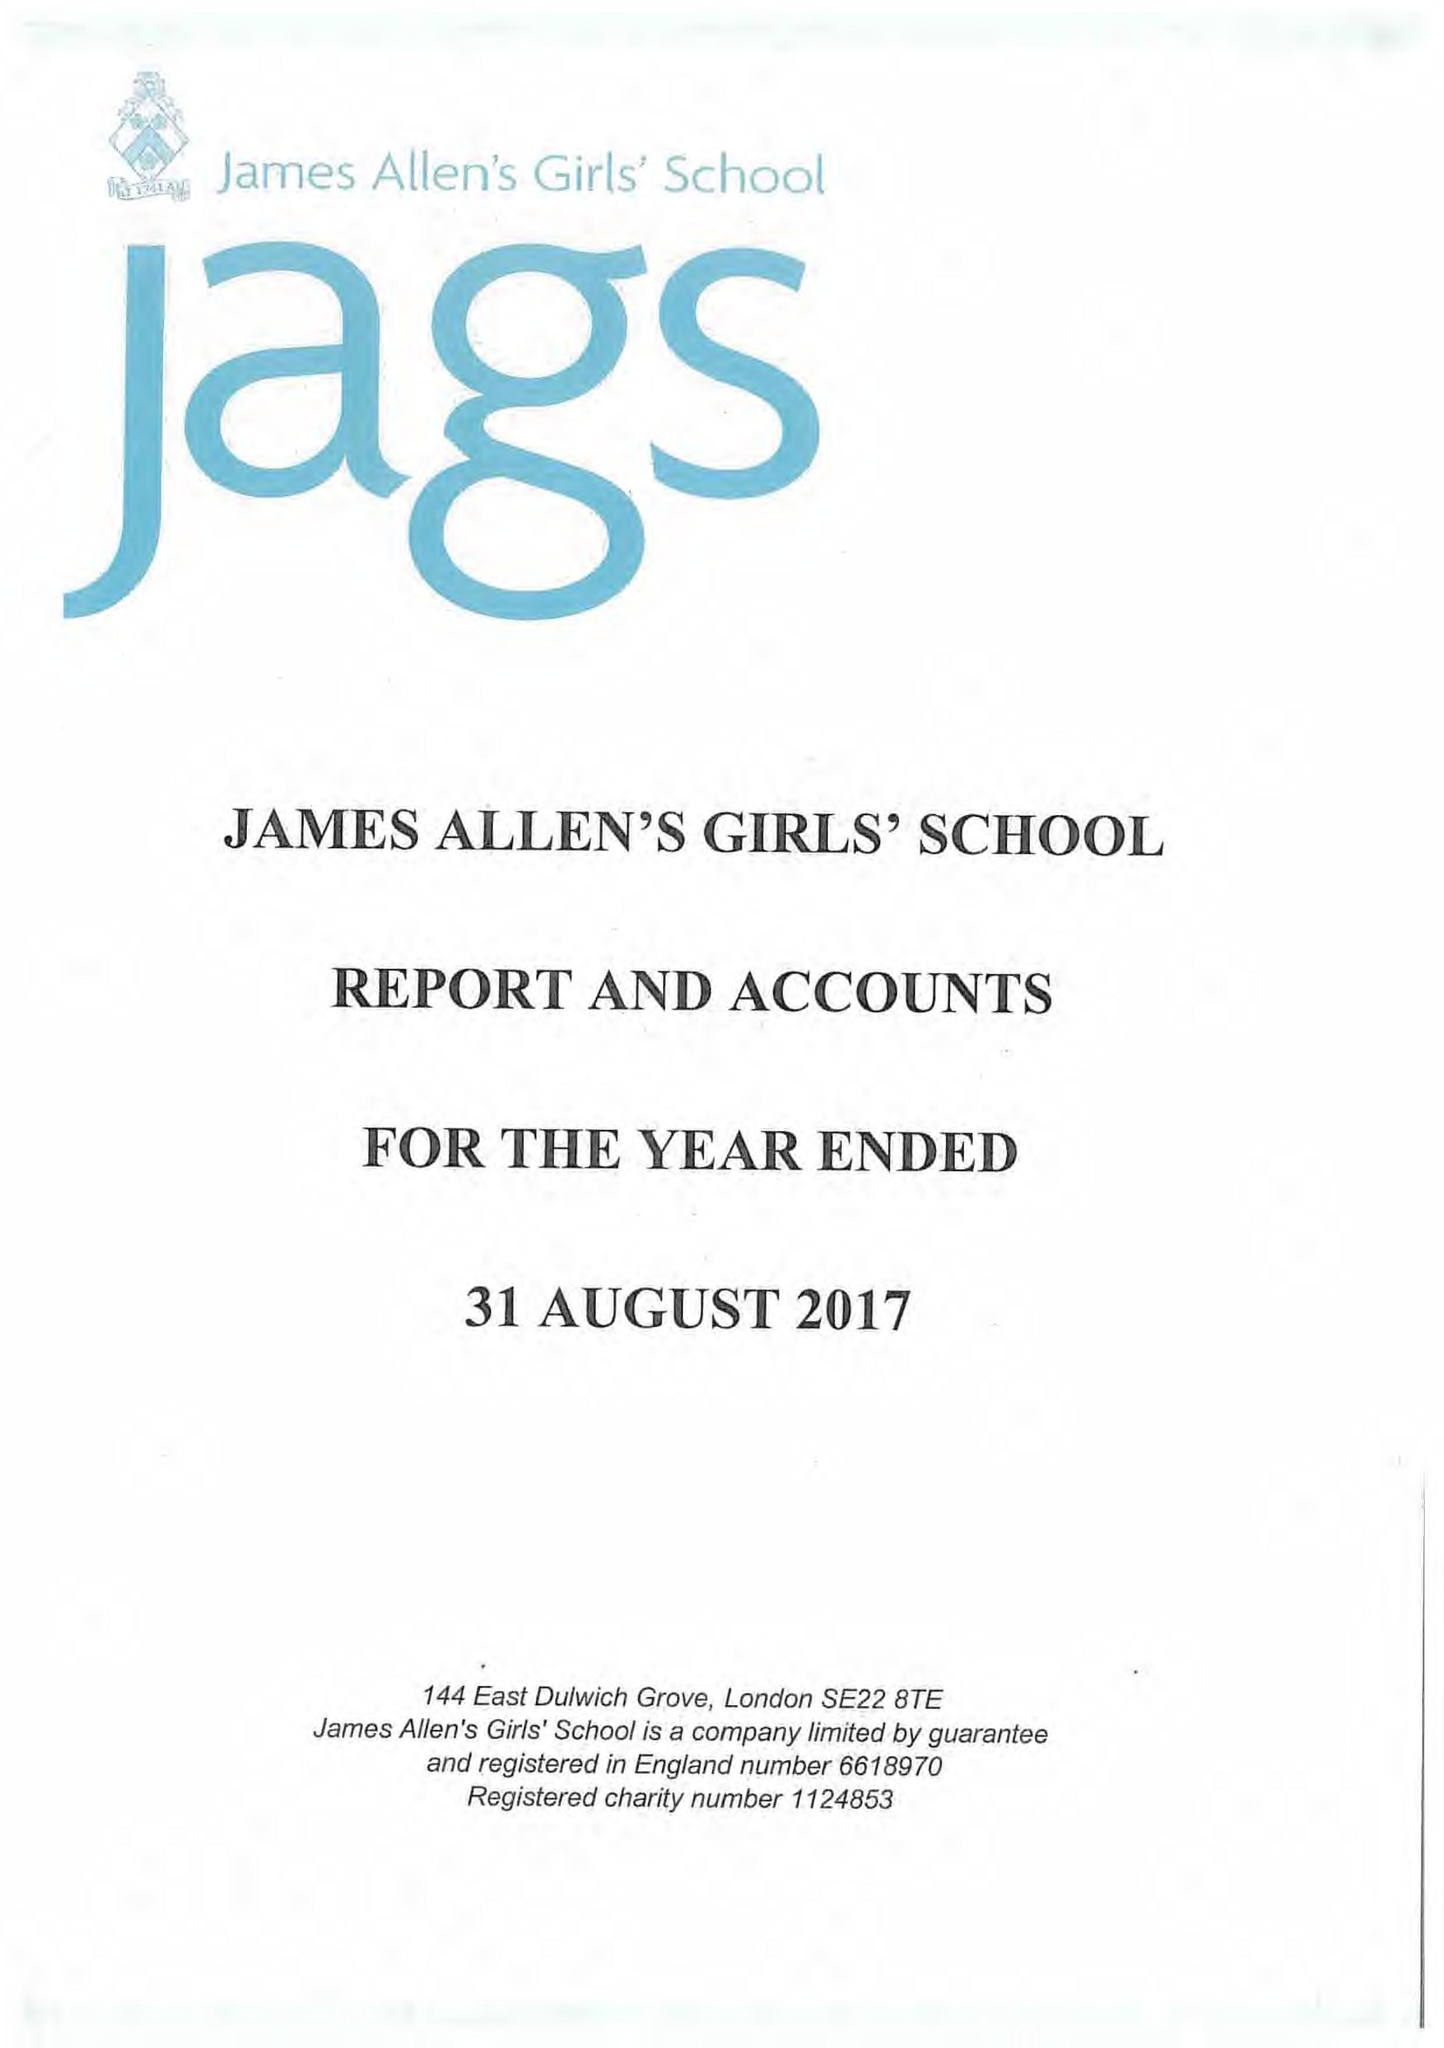What is the value for the charity_name?
Answer the question using a single word or phrase. James Allen's Girls' School 